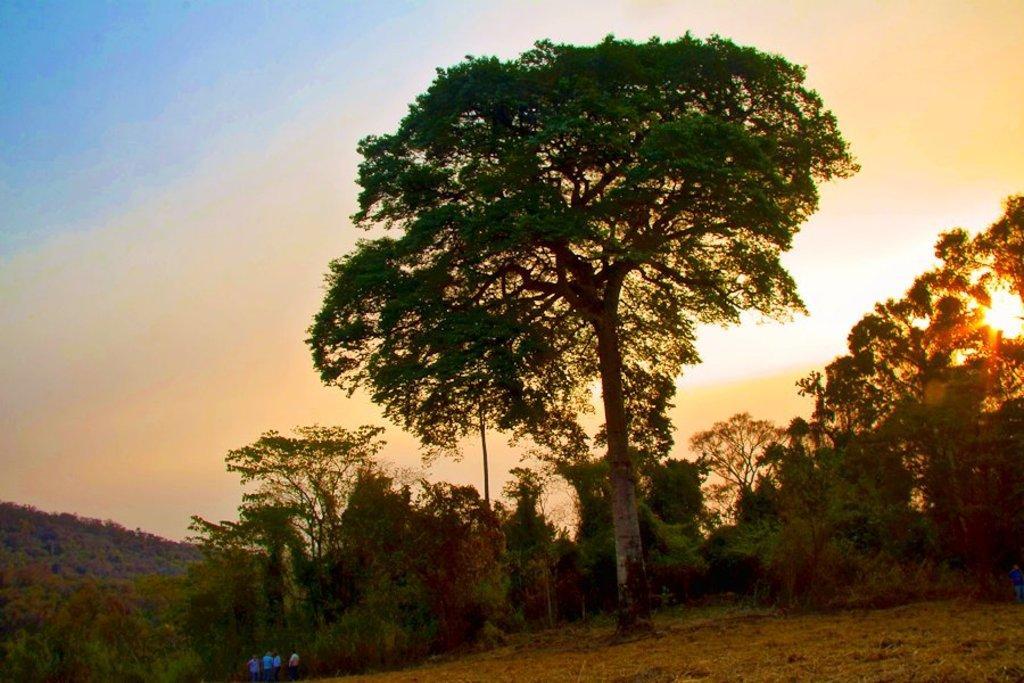Could you give a brief overview of what you see in this image? In this image there are trees. On the right we can see the sun. On the left there is a hill. In the background there is sky. At the bottom there are people. 